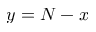Convert formula to latex. <formula><loc_0><loc_0><loc_500><loc_500>y = N - x</formula> 